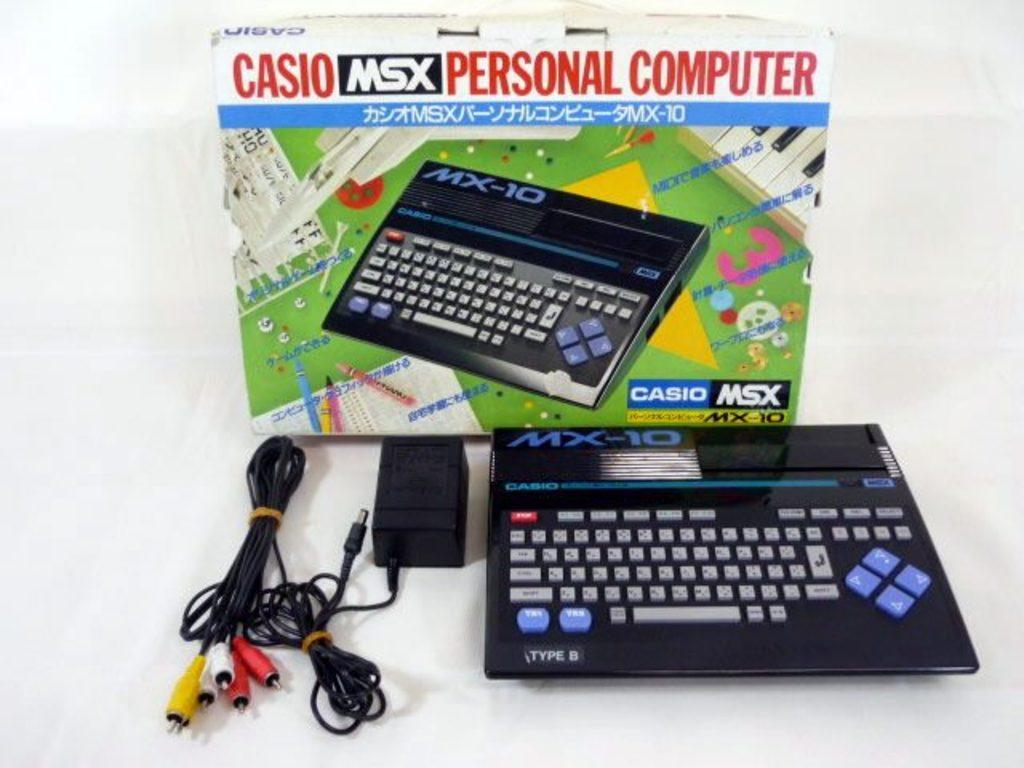<image>
Relay a brief, clear account of the picture shown. a casio personal computer is sitting outside the box that it came in 